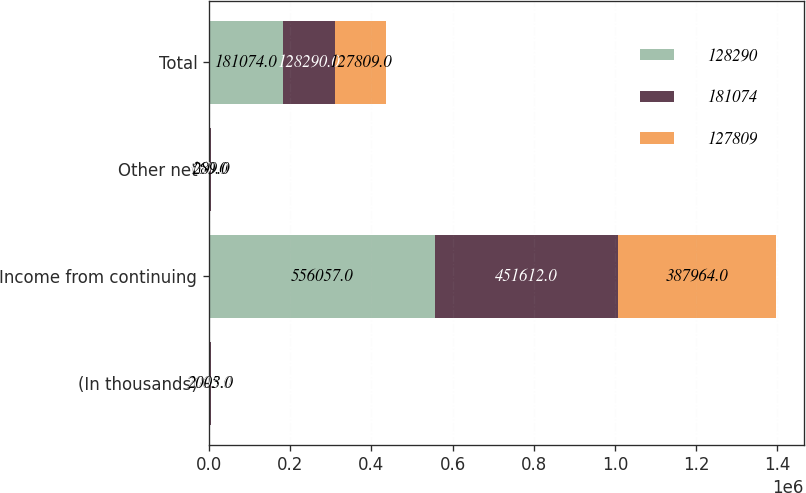Convert chart to OTSL. <chart><loc_0><loc_0><loc_500><loc_500><stacked_bar_chart><ecel><fcel>(In thousands)<fcel>Income from continuing<fcel>Other net<fcel>Total<nl><fcel>128290<fcel>2005<fcel>556057<fcel>160<fcel>181074<nl><fcel>181074<fcel>2004<fcel>451612<fcel>5601<fcel>128290<nl><fcel>127809<fcel>2003<fcel>387964<fcel>289<fcel>127809<nl></chart> 